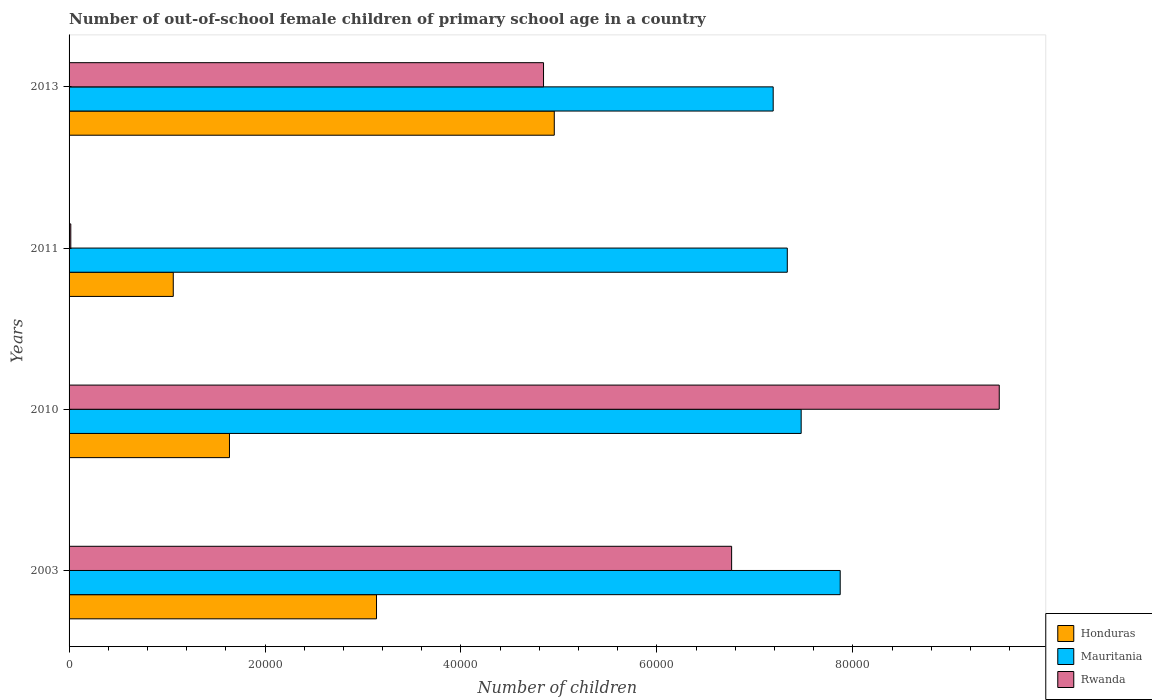How many different coloured bars are there?
Keep it short and to the point. 3. How many groups of bars are there?
Your answer should be compact. 4. What is the label of the 1st group of bars from the top?
Your answer should be very brief. 2013. What is the number of out-of-school female children in Rwanda in 2013?
Your response must be concise. 4.84e+04. Across all years, what is the maximum number of out-of-school female children in Honduras?
Offer a very short reply. 4.95e+04. Across all years, what is the minimum number of out-of-school female children in Honduras?
Give a very brief answer. 1.06e+04. In which year was the number of out-of-school female children in Mauritania minimum?
Ensure brevity in your answer.  2013. What is the total number of out-of-school female children in Honduras in the graph?
Make the answer very short. 1.08e+05. What is the difference between the number of out-of-school female children in Honduras in 2010 and that in 2013?
Your answer should be compact. -3.32e+04. What is the difference between the number of out-of-school female children in Mauritania in 2011 and the number of out-of-school female children in Rwanda in 2003?
Offer a very short reply. 5682. What is the average number of out-of-school female children in Honduras per year?
Keep it short and to the point. 2.70e+04. In the year 2010, what is the difference between the number of out-of-school female children in Mauritania and number of out-of-school female children in Honduras?
Keep it short and to the point. 5.84e+04. In how many years, is the number of out-of-school female children in Rwanda greater than 20000 ?
Ensure brevity in your answer.  3. What is the ratio of the number of out-of-school female children in Honduras in 2003 to that in 2011?
Keep it short and to the point. 2.95. What is the difference between the highest and the second highest number of out-of-school female children in Mauritania?
Make the answer very short. 3984. What is the difference between the highest and the lowest number of out-of-school female children in Mauritania?
Your answer should be compact. 6841. Is the sum of the number of out-of-school female children in Mauritania in 2011 and 2013 greater than the maximum number of out-of-school female children in Rwanda across all years?
Your answer should be compact. Yes. What does the 1st bar from the top in 2011 represents?
Your answer should be very brief. Rwanda. What does the 1st bar from the bottom in 2010 represents?
Provide a succinct answer. Honduras. Is it the case that in every year, the sum of the number of out-of-school female children in Honduras and number of out-of-school female children in Rwanda is greater than the number of out-of-school female children in Mauritania?
Provide a succinct answer. No. How many bars are there?
Provide a short and direct response. 12. What is the difference between two consecutive major ticks on the X-axis?
Ensure brevity in your answer.  2.00e+04. Are the values on the major ticks of X-axis written in scientific E-notation?
Offer a very short reply. No. Does the graph contain any zero values?
Provide a succinct answer. No. Where does the legend appear in the graph?
Ensure brevity in your answer.  Bottom right. How many legend labels are there?
Your answer should be very brief. 3. What is the title of the graph?
Provide a short and direct response. Number of out-of-school female children of primary school age in a country. Does "Latin America(all income levels)" appear as one of the legend labels in the graph?
Keep it short and to the point. No. What is the label or title of the X-axis?
Offer a very short reply. Number of children. What is the label or title of the Y-axis?
Provide a succinct answer. Years. What is the Number of children in Honduras in 2003?
Keep it short and to the point. 3.14e+04. What is the Number of children in Mauritania in 2003?
Make the answer very short. 7.87e+04. What is the Number of children of Rwanda in 2003?
Make the answer very short. 6.76e+04. What is the Number of children in Honduras in 2010?
Provide a short and direct response. 1.64e+04. What is the Number of children in Mauritania in 2010?
Give a very brief answer. 7.47e+04. What is the Number of children in Rwanda in 2010?
Provide a short and direct response. 9.49e+04. What is the Number of children of Honduras in 2011?
Your response must be concise. 1.06e+04. What is the Number of children of Mauritania in 2011?
Make the answer very short. 7.33e+04. What is the Number of children in Rwanda in 2011?
Keep it short and to the point. 176. What is the Number of children in Honduras in 2013?
Give a very brief answer. 4.95e+04. What is the Number of children of Mauritania in 2013?
Your response must be concise. 7.19e+04. What is the Number of children of Rwanda in 2013?
Ensure brevity in your answer.  4.84e+04. Across all years, what is the maximum Number of children of Honduras?
Your answer should be very brief. 4.95e+04. Across all years, what is the maximum Number of children of Mauritania?
Your answer should be very brief. 7.87e+04. Across all years, what is the maximum Number of children in Rwanda?
Ensure brevity in your answer.  9.49e+04. Across all years, what is the minimum Number of children in Honduras?
Ensure brevity in your answer.  1.06e+04. Across all years, what is the minimum Number of children of Mauritania?
Make the answer very short. 7.19e+04. Across all years, what is the minimum Number of children of Rwanda?
Your answer should be very brief. 176. What is the total Number of children in Honduras in the graph?
Give a very brief answer. 1.08e+05. What is the total Number of children in Mauritania in the graph?
Keep it short and to the point. 2.99e+05. What is the total Number of children in Rwanda in the graph?
Offer a terse response. 2.11e+05. What is the difference between the Number of children in Honduras in 2003 and that in 2010?
Your response must be concise. 1.50e+04. What is the difference between the Number of children in Mauritania in 2003 and that in 2010?
Provide a short and direct response. 3984. What is the difference between the Number of children in Rwanda in 2003 and that in 2010?
Ensure brevity in your answer.  -2.73e+04. What is the difference between the Number of children of Honduras in 2003 and that in 2011?
Give a very brief answer. 2.07e+04. What is the difference between the Number of children of Mauritania in 2003 and that in 2011?
Your answer should be very brief. 5401. What is the difference between the Number of children in Rwanda in 2003 and that in 2011?
Offer a very short reply. 6.75e+04. What is the difference between the Number of children of Honduras in 2003 and that in 2013?
Offer a very short reply. -1.81e+04. What is the difference between the Number of children of Mauritania in 2003 and that in 2013?
Ensure brevity in your answer.  6841. What is the difference between the Number of children in Rwanda in 2003 and that in 2013?
Offer a very short reply. 1.92e+04. What is the difference between the Number of children in Honduras in 2010 and that in 2011?
Provide a succinct answer. 5737. What is the difference between the Number of children in Mauritania in 2010 and that in 2011?
Offer a terse response. 1417. What is the difference between the Number of children in Rwanda in 2010 and that in 2011?
Your answer should be very brief. 9.48e+04. What is the difference between the Number of children in Honduras in 2010 and that in 2013?
Your response must be concise. -3.32e+04. What is the difference between the Number of children in Mauritania in 2010 and that in 2013?
Provide a succinct answer. 2857. What is the difference between the Number of children in Rwanda in 2010 and that in 2013?
Your response must be concise. 4.65e+04. What is the difference between the Number of children of Honduras in 2011 and that in 2013?
Ensure brevity in your answer.  -3.89e+04. What is the difference between the Number of children in Mauritania in 2011 and that in 2013?
Provide a succinct answer. 1440. What is the difference between the Number of children of Rwanda in 2011 and that in 2013?
Ensure brevity in your answer.  -4.83e+04. What is the difference between the Number of children of Honduras in 2003 and the Number of children of Mauritania in 2010?
Provide a succinct answer. -4.33e+04. What is the difference between the Number of children of Honduras in 2003 and the Number of children of Rwanda in 2010?
Offer a terse response. -6.36e+04. What is the difference between the Number of children of Mauritania in 2003 and the Number of children of Rwanda in 2010?
Make the answer very short. -1.62e+04. What is the difference between the Number of children in Honduras in 2003 and the Number of children in Mauritania in 2011?
Your answer should be very brief. -4.19e+04. What is the difference between the Number of children in Honduras in 2003 and the Number of children in Rwanda in 2011?
Provide a short and direct response. 3.12e+04. What is the difference between the Number of children of Mauritania in 2003 and the Number of children of Rwanda in 2011?
Your answer should be very brief. 7.85e+04. What is the difference between the Number of children of Honduras in 2003 and the Number of children of Mauritania in 2013?
Keep it short and to the point. -4.05e+04. What is the difference between the Number of children of Honduras in 2003 and the Number of children of Rwanda in 2013?
Provide a succinct answer. -1.70e+04. What is the difference between the Number of children of Mauritania in 2003 and the Number of children of Rwanda in 2013?
Keep it short and to the point. 3.03e+04. What is the difference between the Number of children in Honduras in 2010 and the Number of children in Mauritania in 2011?
Your response must be concise. -5.69e+04. What is the difference between the Number of children of Honduras in 2010 and the Number of children of Rwanda in 2011?
Give a very brief answer. 1.62e+04. What is the difference between the Number of children in Mauritania in 2010 and the Number of children in Rwanda in 2011?
Your response must be concise. 7.46e+04. What is the difference between the Number of children of Honduras in 2010 and the Number of children of Mauritania in 2013?
Provide a succinct answer. -5.55e+04. What is the difference between the Number of children in Honduras in 2010 and the Number of children in Rwanda in 2013?
Keep it short and to the point. -3.21e+04. What is the difference between the Number of children of Mauritania in 2010 and the Number of children of Rwanda in 2013?
Give a very brief answer. 2.63e+04. What is the difference between the Number of children of Honduras in 2011 and the Number of children of Mauritania in 2013?
Keep it short and to the point. -6.12e+04. What is the difference between the Number of children in Honduras in 2011 and the Number of children in Rwanda in 2013?
Give a very brief answer. -3.78e+04. What is the difference between the Number of children in Mauritania in 2011 and the Number of children in Rwanda in 2013?
Make the answer very short. 2.49e+04. What is the average Number of children in Honduras per year?
Make the answer very short. 2.70e+04. What is the average Number of children of Mauritania per year?
Keep it short and to the point. 7.47e+04. What is the average Number of children in Rwanda per year?
Offer a terse response. 5.28e+04. In the year 2003, what is the difference between the Number of children of Honduras and Number of children of Mauritania?
Make the answer very short. -4.73e+04. In the year 2003, what is the difference between the Number of children in Honduras and Number of children in Rwanda?
Your response must be concise. -3.62e+04. In the year 2003, what is the difference between the Number of children in Mauritania and Number of children in Rwanda?
Provide a short and direct response. 1.11e+04. In the year 2010, what is the difference between the Number of children in Honduras and Number of children in Mauritania?
Your response must be concise. -5.84e+04. In the year 2010, what is the difference between the Number of children of Honduras and Number of children of Rwanda?
Keep it short and to the point. -7.86e+04. In the year 2010, what is the difference between the Number of children in Mauritania and Number of children in Rwanda?
Offer a terse response. -2.02e+04. In the year 2011, what is the difference between the Number of children in Honduras and Number of children in Mauritania?
Offer a very short reply. -6.27e+04. In the year 2011, what is the difference between the Number of children in Honduras and Number of children in Rwanda?
Your answer should be compact. 1.05e+04. In the year 2011, what is the difference between the Number of children of Mauritania and Number of children of Rwanda?
Your answer should be compact. 7.31e+04. In the year 2013, what is the difference between the Number of children of Honduras and Number of children of Mauritania?
Provide a succinct answer. -2.23e+04. In the year 2013, what is the difference between the Number of children of Honduras and Number of children of Rwanda?
Offer a very short reply. 1098. In the year 2013, what is the difference between the Number of children in Mauritania and Number of children in Rwanda?
Ensure brevity in your answer.  2.34e+04. What is the ratio of the Number of children in Honduras in 2003 to that in 2010?
Make the answer very short. 1.92. What is the ratio of the Number of children in Mauritania in 2003 to that in 2010?
Provide a succinct answer. 1.05. What is the ratio of the Number of children of Rwanda in 2003 to that in 2010?
Give a very brief answer. 0.71. What is the ratio of the Number of children of Honduras in 2003 to that in 2011?
Your response must be concise. 2.95. What is the ratio of the Number of children of Mauritania in 2003 to that in 2011?
Make the answer very short. 1.07. What is the ratio of the Number of children in Rwanda in 2003 to that in 2011?
Ensure brevity in your answer.  384.24. What is the ratio of the Number of children in Honduras in 2003 to that in 2013?
Offer a terse response. 0.63. What is the ratio of the Number of children of Mauritania in 2003 to that in 2013?
Offer a very short reply. 1.1. What is the ratio of the Number of children of Rwanda in 2003 to that in 2013?
Provide a succinct answer. 1.4. What is the ratio of the Number of children of Honduras in 2010 to that in 2011?
Keep it short and to the point. 1.54. What is the ratio of the Number of children in Mauritania in 2010 to that in 2011?
Keep it short and to the point. 1.02. What is the ratio of the Number of children of Rwanda in 2010 to that in 2011?
Ensure brevity in your answer.  539.45. What is the ratio of the Number of children of Honduras in 2010 to that in 2013?
Your response must be concise. 0.33. What is the ratio of the Number of children in Mauritania in 2010 to that in 2013?
Your response must be concise. 1.04. What is the ratio of the Number of children of Rwanda in 2010 to that in 2013?
Offer a very short reply. 1.96. What is the ratio of the Number of children in Honduras in 2011 to that in 2013?
Offer a terse response. 0.21. What is the ratio of the Number of children in Rwanda in 2011 to that in 2013?
Your answer should be very brief. 0. What is the difference between the highest and the second highest Number of children in Honduras?
Your response must be concise. 1.81e+04. What is the difference between the highest and the second highest Number of children of Mauritania?
Offer a very short reply. 3984. What is the difference between the highest and the second highest Number of children of Rwanda?
Your response must be concise. 2.73e+04. What is the difference between the highest and the lowest Number of children in Honduras?
Offer a terse response. 3.89e+04. What is the difference between the highest and the lowest Number of children of Mauritania?
Provide a short and direct response. 6841. What is the difference between the highest and the lowest Number of children of Rwanda?
Your answer should be very brief. 9.48e+04. 